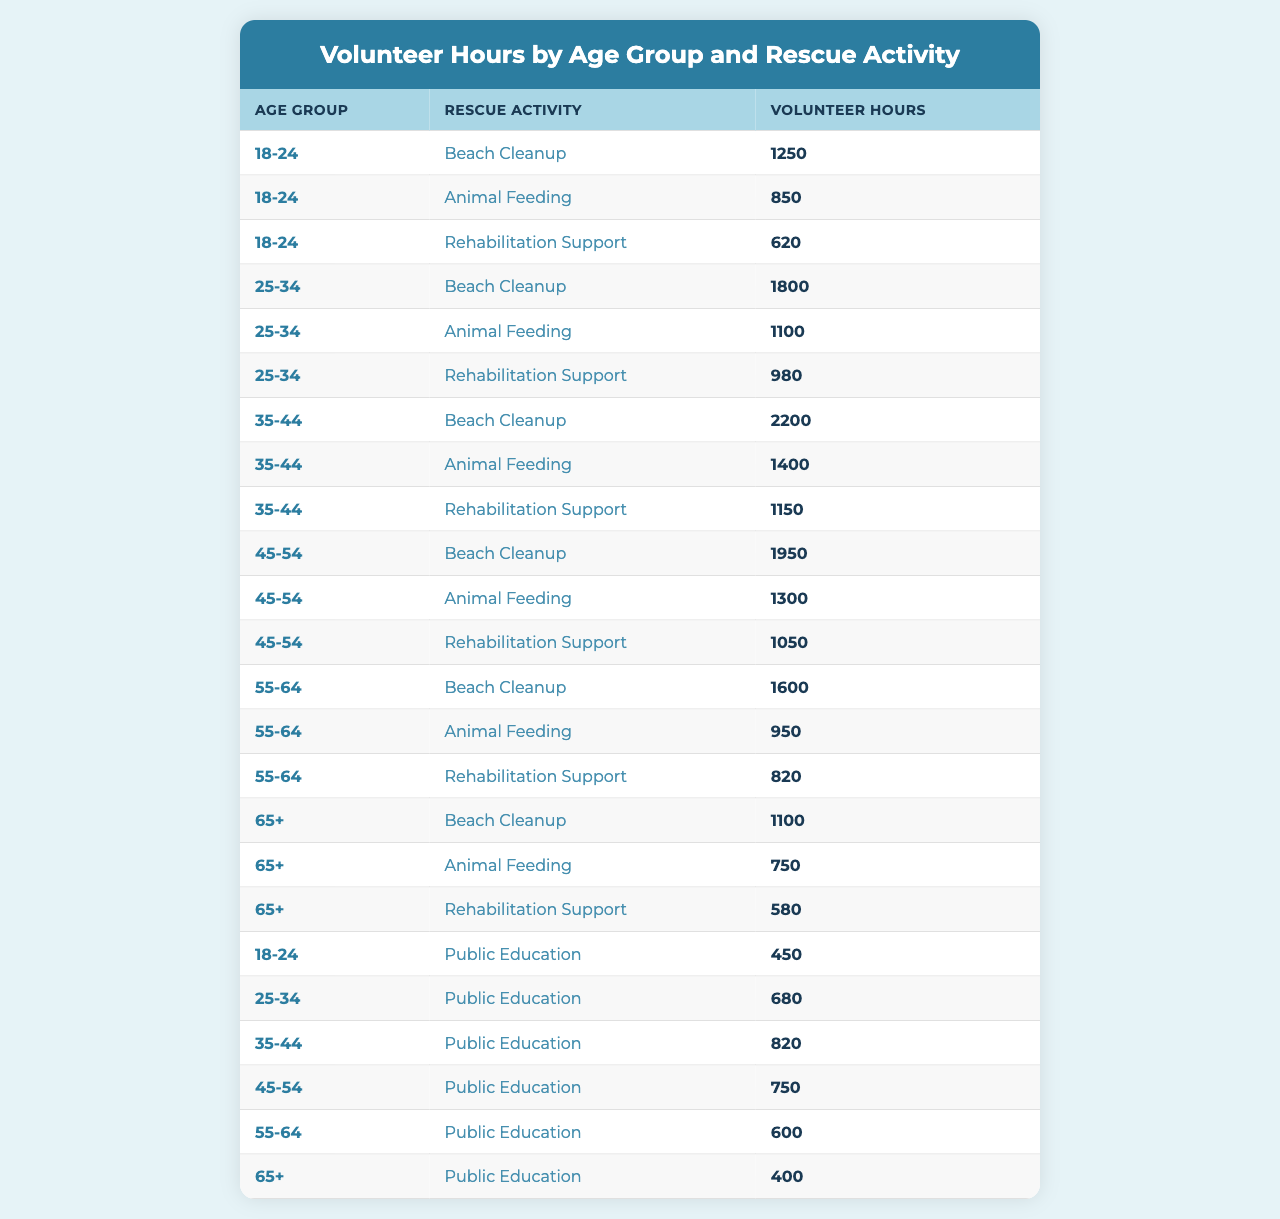What is the total number of volunteer hours contributed by the age group 25-34? To find the total for the age group 25-34, we need to sum the volunteer hours for all activities in that age range. The hours are 1800 (Beach Cleanup) + 1100 (Animal Feeding) + 980 (Rehabilitation Support) + 680 (Public Education) = 3560.
Answer: 3560 Which rescue activity received the most volunteer hours from the age group 35-44? In the age group 35-44, the volunteer hours for each activity are: 2200 (Beach Cleanup), 1400 (Animal Feeding), 1150 (Rehabilitation Support), and 820 (Public Education). The maximum is 2200, which is for Beach Cleanup.
Answer: Beach Cleanup How many hours were spent on Animal Feeding across all age groups? We need to sum the volunteer hours for Animal Feeding from all age groups. They are: 850 (18-24) + 1100 (25-34) + 1400 (35-44) + 1300 (45-54) + 950 (55-64) + 750 (65+) = 5250.
Answer: 5250 What is the average number of volunteer hours contributed for Rehabilitation Support by the age group 45-54? The age group 45-54 has only one entry for Rehabilitation Support, which is 1050 hours. Since there's only one value, the average is the same as that value.
Answer: 1050 True or False: The age group 65+ contributed more hours to Beach Cleanup than the age group 18-24. The hours for Beach Cleanup are 1100 for age group 65+ and 1250 for age group 18-24. Since 1100 is less than 1250, the statement is false.
Answer: False Which age group contributed the least volunteer hours to Public Education? Summing the hours for Public Education by age group gives: 450 (18-24), 680 (25-34), 820 (35-44), 750 (45-54), 600 (55-64), 400 (65+). The least is 400 from the 65+ age group.
Answer: 65+ What is the difference in total volunteer hours between the age group 35-44 and 55-64 across all activities? We first sum the hours for each group: For 35-44: 2200 + 1400 + 1150 + 820 = 4570; For 55-64: 1600 + 950 + 820 + 600 = 3970. The difference is 4570 - 3970 = 600.
Answer: 600 Which activity had the highest overall volunteer hours from all age groups combined? We sum the volunteer hours for each activity: Beach Cleanup (1250 + 1800 + 2200 + 1950 + 1600 + 1100 = 10800), Animal Feeding (850 + 1100 + 1400 + 1300 + 950 + 750 = 5450), Rehabilitation Support (620 + 980 + 1150 + 1050 + 820 + 580 = 4200), Public Education (450 + 680 + 820 + 750 + 600 + 400 = 3900). The highest is Beach Cleanup with 10800 hours.
Answer: Beach Cleanup What is the combined total of volunteer hours for the youngest age group (18-24) across all activities? We add the hours for the 18-24 age group: 1250 (Beach Cleanup) + 850 (Animal Feeding) + 620 (Rehabilitation Support) + 450 (Public Education) = 3170.
Answer: 3170 